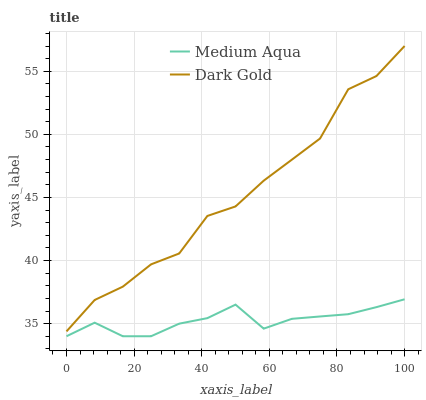Does Medium Aqua have the minimum area under the curve?
Answer yes or no. Yes. Does Dark Gold have the maximum area under the curve?
Answer yes or no. Yes. Does Dark Gold have the minimum area under the curve?
Answer yes or no. No. Is Medium Aqua the smoothest?
Answer yes or no. Yes. Is Dark Gold the roughest?
Answer yes or no. Yes. Is Dark Gold the smoothest?
Answer yes or no. No. Does Medium Aqua have the lowest value?
Answer yes or no. Yes. Does Dark Gold have the lowest value?
Answer yes or no. No. Does Dark Gold have the highest value?
Answer yes or no. Yes. Is Medium Aqua less than Dark Gold?
Answer yes or no. Yes. Is Dark Gold greater than Medium Aqua?
Answer yes or no. Yes. Does Medium Aqua intersect Dark Gold?
Answer yes or no. No. 